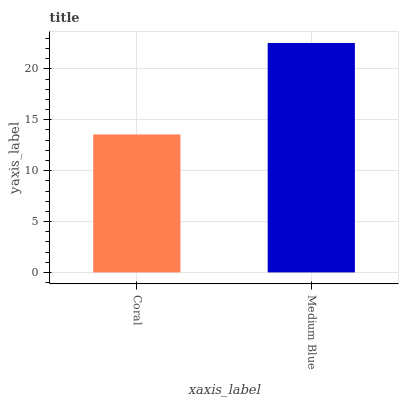Is Medium Blue the minimum?
Answer yes or no. No. Is Medium Blue greater than Coral?
Answer yes or no. Yes. Is Coral less than Medium Blue?
Answer yes or no. Yes. Is Coral greater than Medium Blue?
Answer yes or no. No. Is Medium Blue less than Coral?
Answer yes or no. No. Is Medium Blue the high median?
Answer yes or no. Yes. Is Coral the low median?
Answer yes or no. Yes. Is Coral the high median?
Answer yes or no. No. Is Medium Blue the low median?
Answer yes or no. No. 